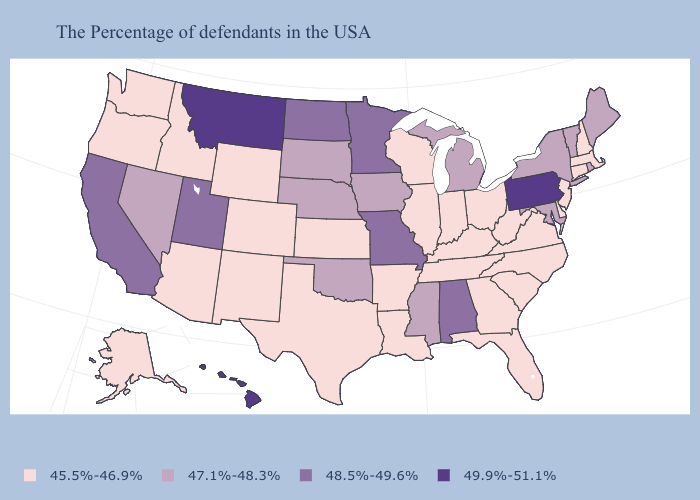Name the states that have a value in the range 47.1%-48.3%?
Quick response, please. Maine, Rhode Island, Vermont, New York, Maryland, Michigan, Mississippi, Iowa, Nebraska, Oklahoma, South Dakota, Nevada. Name the states that have a value in the range 48.5%-49.6%?
Quick response, please. Alabama, Missouri, Minnesota, North Dakota, Utah, California. What is the value of Texas?
Answer briefly. 45.5%-46.9%. What is the value of New Hampshire?
Keep it brief. 45.5%-46.9%. What is the lowest value in states that border New York?
Concise answer only. 45.5%-46.9%. Which states have the lowest value in the Northeast?
Quick response, please. Massachusetts, New Hampshire, Connecticut, New Jersey. Name the states that have a value in the range 49.9%-51.1%?
Be succinct. Pennsylvania, Montana, Hawaii. Among the states that border Oklahoma , which have the lowest value?
Write a very short answer. Arkansas, Kansas, Texas, Colorado, New Mexico. What is the lowest value in the USA?
Be succinct. 45.5%-46.9%. Among the states that border Montana , which have the lowest value?
Write a very short answer. Wyoming, Idaho. What is the value of Hawaii?
Concise answer only. 49.9%-51.1%. Does the first symbol in the legend represent the smallest category?
Keep it brief. Yes. Which states hav the highest value in the Northeast?
Write a very short answer. Pennsylvania. What is the value of Oregon?
Write a very short answer. 45.5%-46.9%. 